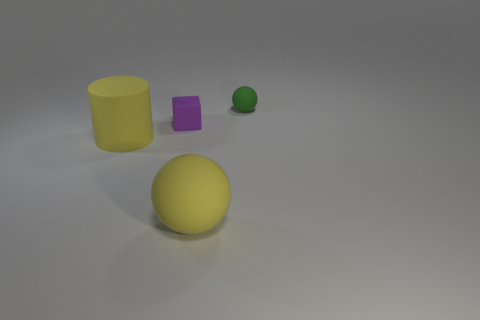What is the material of the green ball that is the same size as the purple cube?
Provide a succinct answer. Rubber. Is the size of the ball that is in front of the small ball the same as the thing that is behind the cube?
Provide a short and direct response. No. How many things are either small purple metal cubes or objects in front of the purple rubber object?
Make the answer very short. 2. Is there another small object that has the same shape as the small purple matte object?
Your answer should be compact. No. There is a rubber ball behind the large thing that is on the right side of the small purple rubber block; what size is it?
Your answer should be very brief. Small. Do the rubber cylinder and the big sphere have the same color?
Offer a very short reply. Yes. How many rubber objects are tiny purple things or big balls?
Ensure brevity in your answer.  2. What number of matte objects are there?
Offer a terse response. 4. The other thing that is the same shape as the tiny green object is what color?
Make the answer very short. Yellow. What material is the yellow thing left of the large object that is right of the small block?
Offer a terse response. Rubber. 